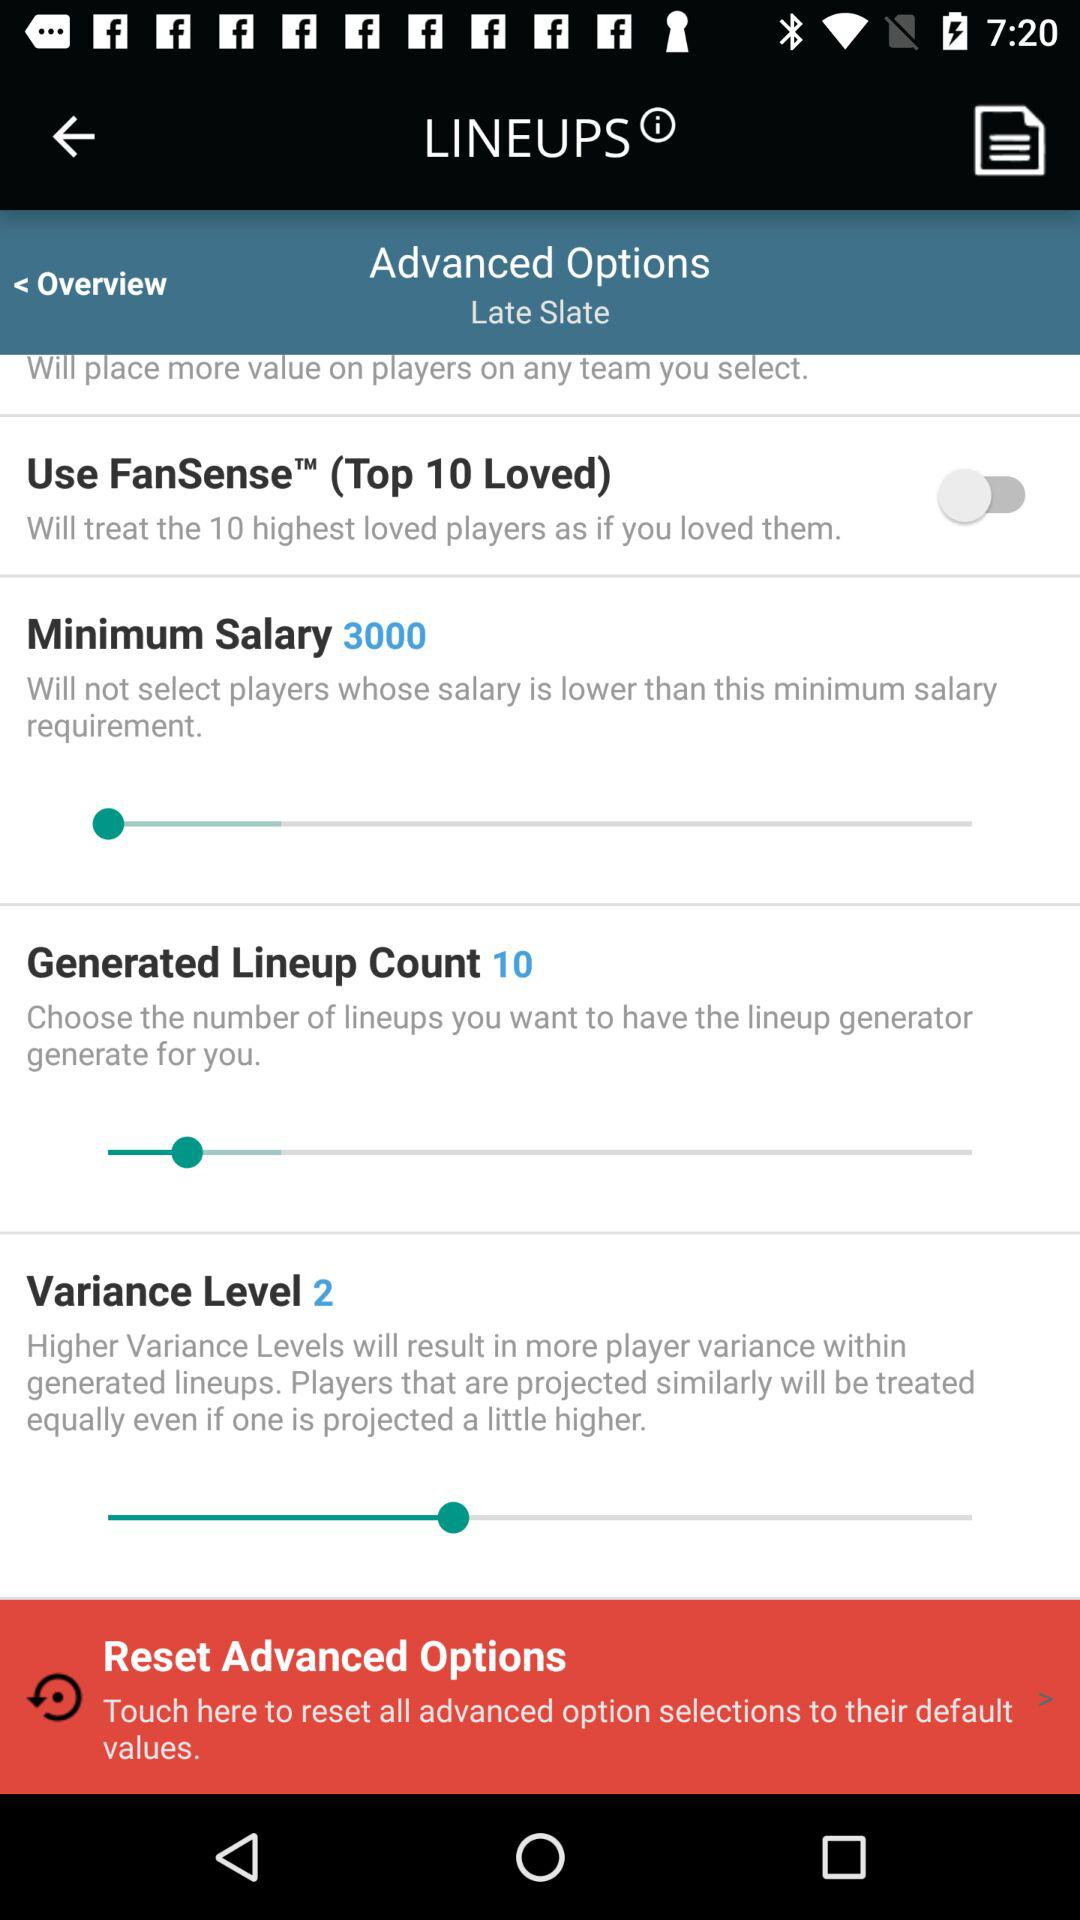What is the count of the generated lineup? The count is 10. 